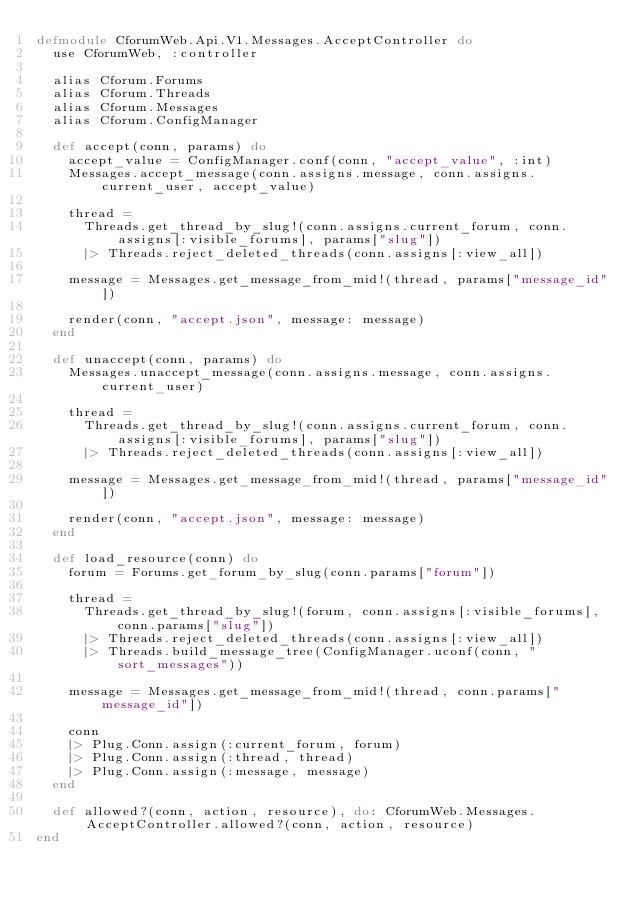Convert code to text. <code><loc_0><loc_0><loc_500><loc_500><_Elixir_>defmodule CforumWeb.Api.V1.Messages.AcceptController do
  use CforumWeb, :controller

  alias Cforum.Forums
  alias Cforum.Threads
  alias Cforum.Messages
  alias Cforum.ConfigManager

  def accept(conn, params) do
    accept_value = ConfigManager.conf(conn, "accept_value", :int)
    Messages.accept_message(conn.assigns.message, conn.assigns.current_user, accept_value)

    thread =
      Threads.get_thread_by_slug!(conn.assigns.current_forum, conn.assigns[:visible_forums], params["slug"])
      |> Threads.reject_deleted_threads(conn.assigns[:view_all])

    message = Messages.get_message_from_mid!(thread, params["message_id"])

    render(conn, "accept.json", message: message)
  end

  def unaccept(conn, params) do
    Messages.unaccept_message(conn.assigns.message, conn.assigns.current_user)

    thread =
      Threads.get_thread_by_slug!(conn.assigns.current_forum, conn.assigns[:visible_forums], params["slug"])
      |> Threads.reject_deleted_threads(conn.assigns[:view_all])

    message = Messages.get_message_from_mid!(thread, params["message_id"])

    render(conn, "accept.json", message: message)
  end

  def load_resource(conn) do
    forum = Forums.get_forum_by_slug(conn.params["forum"])

    thread =
      Threads.get_thread_by_slug!(forum, conn.assigns[:visible_forums], conn.params["slug"])
      |> Threads.reject_deleted_threads(conn.assigns[:view_all])
      |> Threads.build_message_tree(ConfigManager.uconf(conn, "sort_messages"))

    message = Messages.get_message_from_mid!(thread, conn.params["message_id"])

    conn
    |> Plug.Conn.assign(:current_forum, forum)
    |> Plug.Conn.assign(:thread, thread)
    |> Plug.Conn.assign(:message, message)
  end

  def allowed?(conn, action, resource), do: CforumWeb.Messages.AcceptController.allowed?(conn, action, resource)
end
</code> 